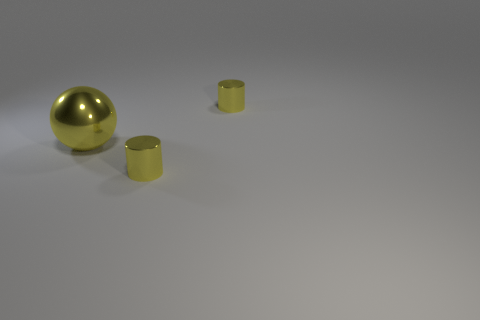What material is the yellow cylinder left of the yellow object on the right side of the yellow shiny object that is in front of the yellow shiny sphere?
Ensure brevity in your answer.  Metal. What number of things are small yellow shiny things that are behind the sphere or big gray metal cylinders?
Your response must be concise. 1. What number of other things are the same shape as the large yellow metallic thing?
Offer a terse response. 0. Are there more small yellow metallic objects left of the large yellow thing than big yellow rubber cubes?
Keep it short and to the point. No. Are there any other things that have the same material as the large yellow object?
Your response must be concise. Yes. The large yellow thing is what shape?
Offer a terse response. Sphere. Are there any other things that are the same color as the large object?
Your answer should be compact. Yes. Do the big yellow object and the yellow object that is behind the big metal thing have the same shape?
Provide a short and direct response. No. The yellow shiny ball is what size?
Provide a succinct answer. Large. Is the number of objects behind the big yellow metal ball less than the number of big yellow metal balls?
Your response must be concise. No. 